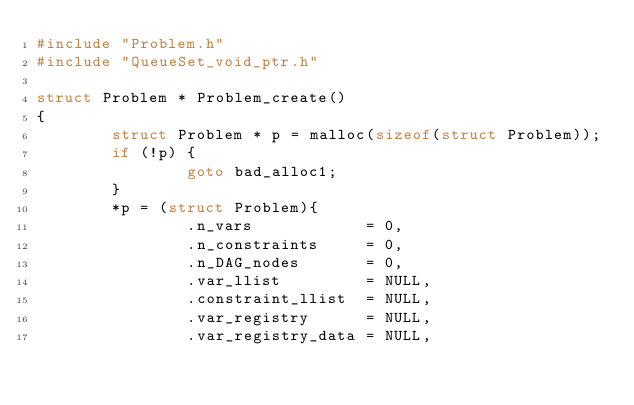Convert code to text. <code><loc_0><loc_0><loc_500><loc_500><_C_>#include "Problem.h"
#include "QueueSet_void_ptr.h"

struct Problem * Problem_create()
{
        struct Problem * p = malloc(sizeof(struct Problem));
        if (!p) {
                goto bad_alloc1;
        }
        *p = (struct Problem){
                .n_vars            = 0,
                .n_constraints     = 0,
                .n_DAG_nodes       = 0,
                .var_llist         = NULL,
                .constraint_llist  = NULL,
                .var_registry      = NULL,
                .var_registry_data = NULL,</code> 